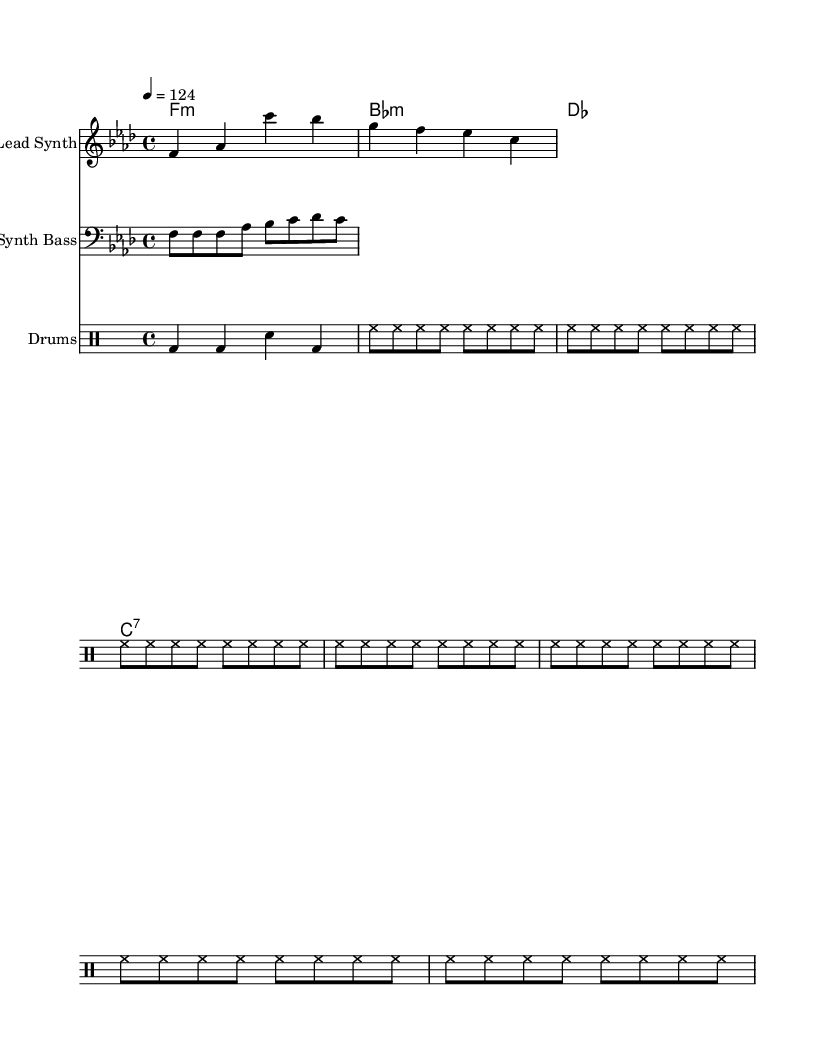What is the key signature of this music? The key signature is F minor, which is indicated by four flats on the staff. These flats are B♭, E♭, A♭, and D♭. This is deduced from the global section in the code where "f \minor" specifies the key.
Answer: F minor What is the time signature of the piece? The time signature is 4/4, which is indicated in the global section of the score with "4/4" after the "\time" command. This means there are four beats per measure, and each beat is a quarter note.
Answer: 4/4 What is the tempo marking? The tempo marking is 124 beats per minute, specified in the global section with "4 = 124". This indicates the speed of the music.
Answer: 124 What type of chords are primarily used in the harmony? The primary chords used are minor chords and a seventh chord, as indicated by "m" for minor and ":7" for the seventh chord in the harmonyChords section. This structure is typical in house music for creating a funky feel.
Answer: Minor and seventh What instruments are indicated in the score? The score includes three instruments: Lead Synth, Synth Bass, and Drums, specified by the "instrumentName" in each Staff and DrumStaff section. This diversity adds to the disco house vibe.
Answer: Lead Synth, Synth Bass, Drums What rhythmic pattern is used for the drums? The drum pattern shows a kick drum (bd) and a snare drum (sn) in a typical four-on-the-floor rhythm, with hi-hat (hh) playing consistently throughout, which creates a driving dance beat essential for house music.
Answer: Four-on-the-floor 